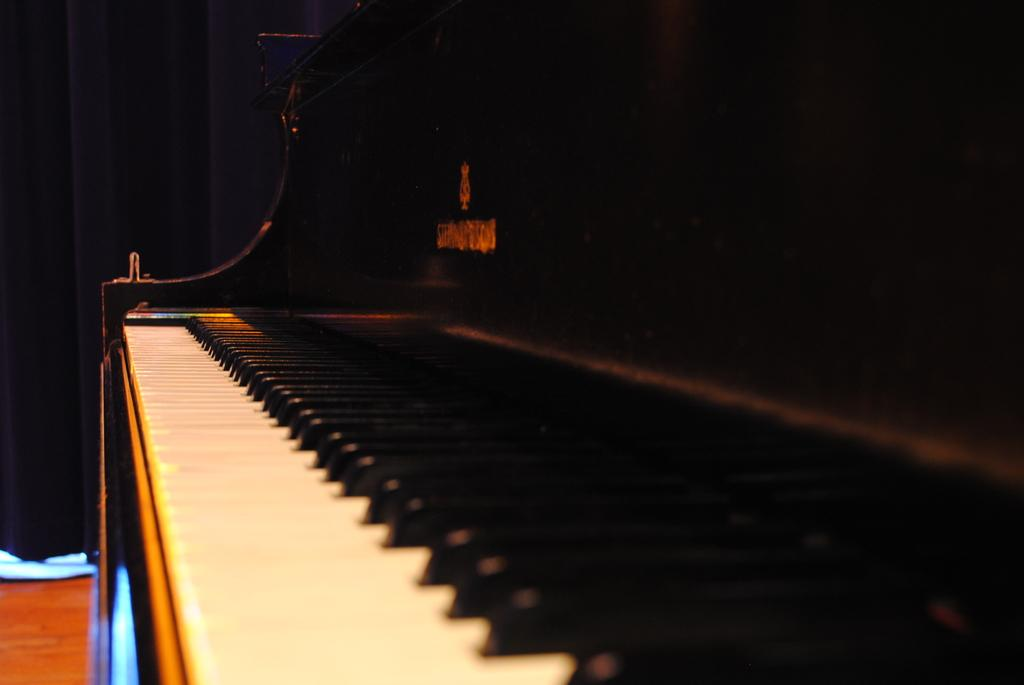What object is the main focus of the image? There is a keyboard in the image. What can be observed about the keys on the keyboard? The keyboard has white keys and black keys. What is the purpose of the keyboard in the image? The keyboard is a musical instrument. What is present on the right side of the image? There is a curtain on the right side of the image. What is the color of the curtain on the right side? The curtain on the right side is black in color. What is present in the left side top corner of the image? The left side top corner of the image has a black curtain. What grade does the sweater receive in the image? There is no sweater present in the image, so it cannot receive a grade. How does the heat affect the keyboard in the image? There is no indication of heat in the image, so its effect on the keyboard cannot be determined. 